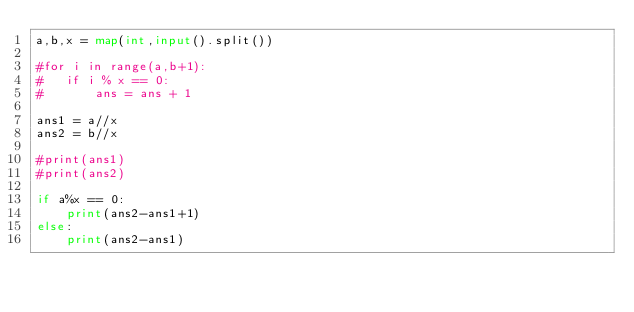<code> <loc_0><loc_0><loc_500><loc_500><_Python_>a,b,x = map(int,input().split())

#for i in range(a,b+1):
#	if i % x == 0:
#		ans = ans + 1

ans1 = a//x
ans2 = b//x

#print(ans1)
#print(ans2)

if a%x == 0:
	print(ans2-ans1+1)
else:
	print(ans2-ans1)
</code> 